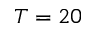Convert formula to latex. <formula><loc_0><loc_0><loc_500><loc_500>T = 2 0</formula> 